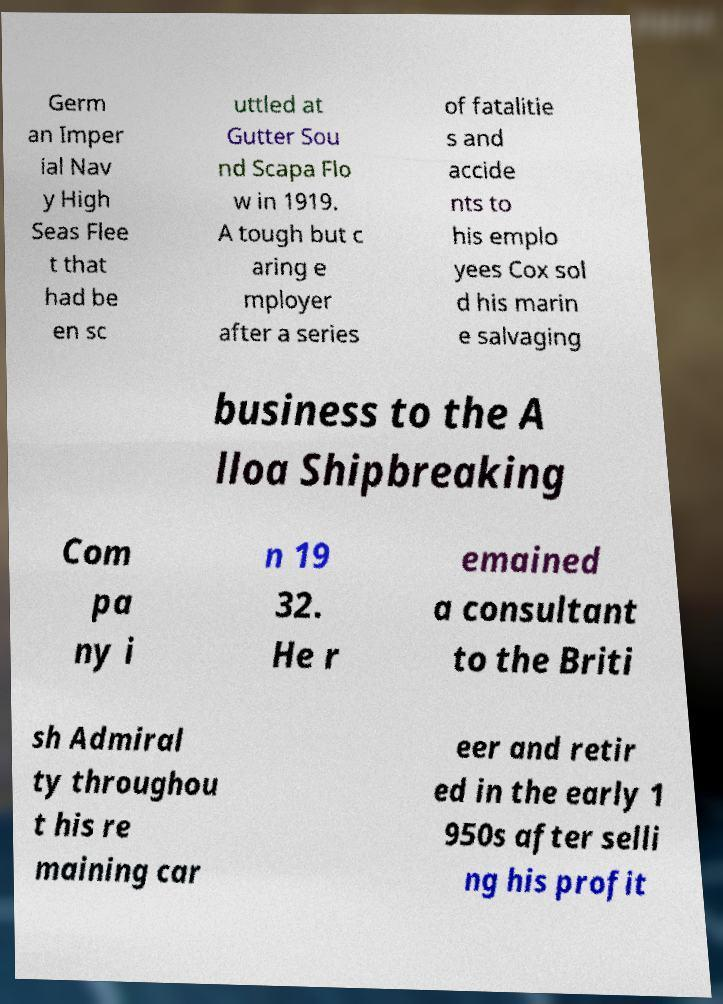For documentation purposes, I need the text within this image transcribed. Could you provide that? Germ an Imper ial Nav y High Seas Flee t that had be en sc uttled at Gutter Sou nd Scapa Flo w in 1919. A tough but c aring e mployer after a series of fatalitie s and accide nts to his emplo yees Cox sol d his marin e salvaging business to the A lloa Shipbreaking Com pa ny i n 19 32. He r emained a consultant to the Briti sh Admiral ty throughou t his re maining car eer and retir ed in the early 1 950s after selli ng his profit 